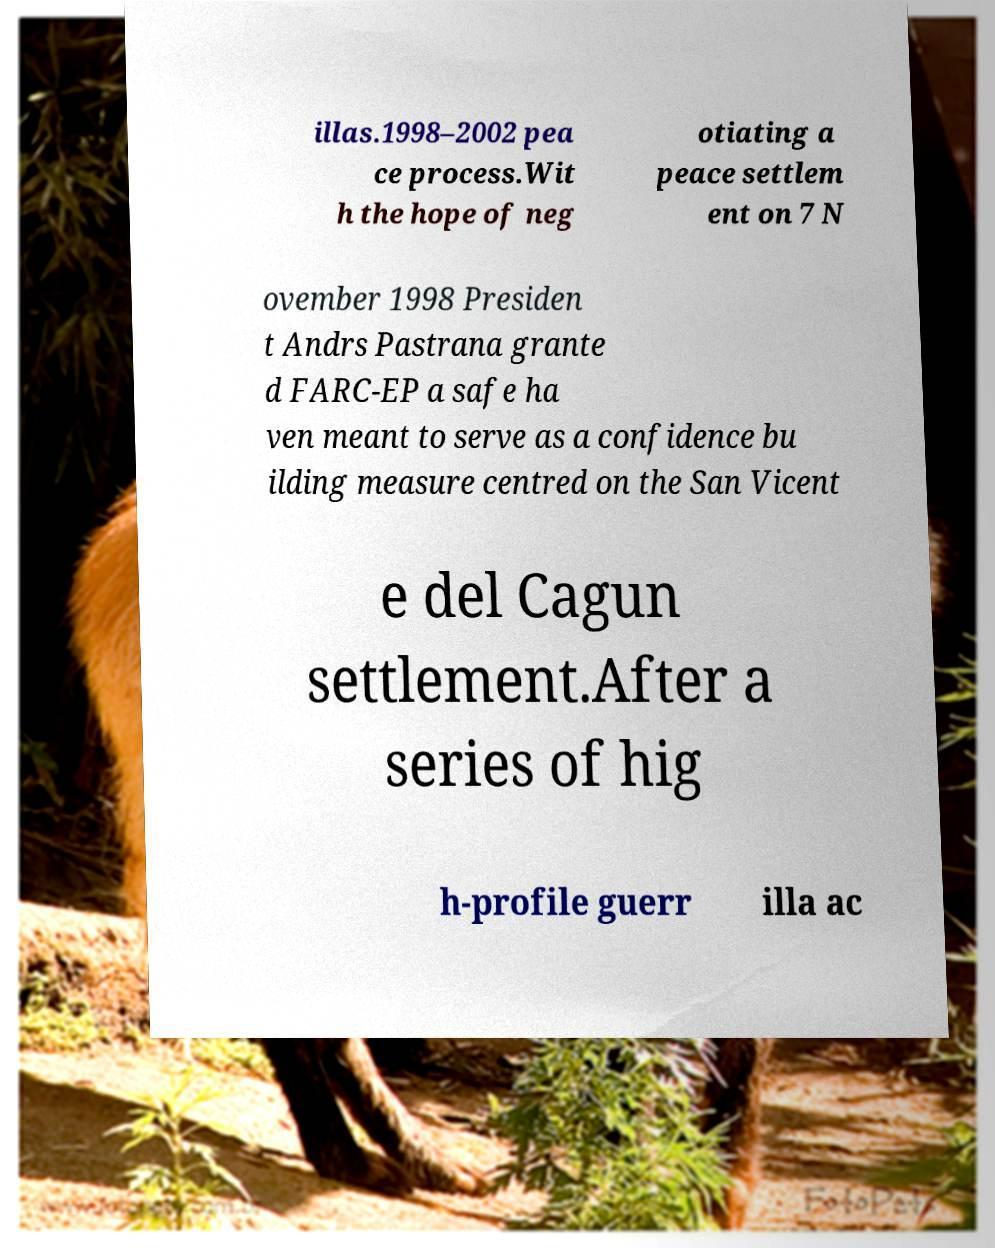Please read and relay the text visible in this image. What does it say? illas.1998–2002 pea ce process.Wit h the hope of neg otiating a peace settlem ent on 7 N ovember 1998 Presiden t Andrs Pastrana grante d FARC-EP a safe ha ven meant to serve as a confidence bu ilding measure centred on the San Vicent e del Cagun settlement.After a series of hig h-profile guerr illa ac 